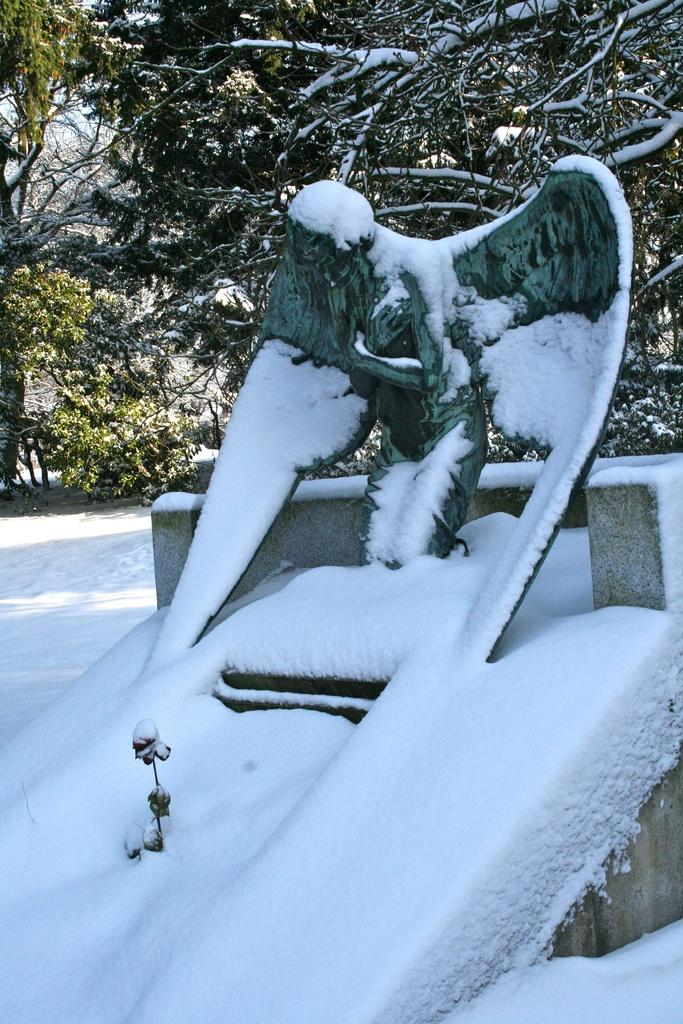What is the main subject of the image? There is a statue of a person in the image. What can be seen in the background of the image? There are trees and snow visible in the background of the image. Are there any other objects in the background of the image? Yes, there are other objects in the background of the image. What is the taste of the statue in the image? The statue is not something that can be tasted, as it is a sculpture made of a solid material. 